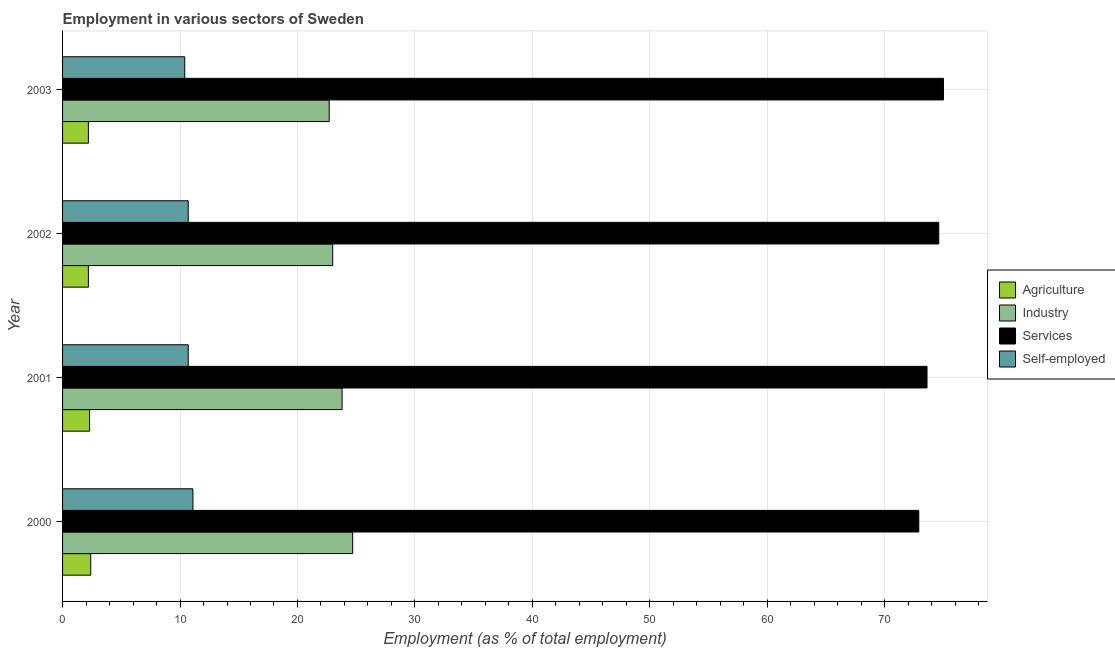How many groups of bars are there?
Make the answer very short. 4. Are the number of bars per tick equal to the number of legend labels?
Keep it short and to the point. Yes. How many bars are there on the 3rd tick from the top?
Give a very brief answer. 4. What is the percentage of workers in agriculture in 2002?
Your answer should be compact. 2.2. Across all years, what is the minimum percentage of workers in agriculture?
Your answer should be very brief. 2.2. In which year was the percentage of workers in services minimum?
Your answer should be very brief. 2000. What is the total percentage of workers in services in the graph?
Ensure brevity in your answer.  296.1. What is the difference between the percentage of workers in agriculture in 2000 and the percentage of workers in services in 2003?
Your response must be concise. -72.6. What is the average percentage of self employed workers per year?
Keep it short and to the point. 10.72. In the year 2003, what is the difference between the percentage of self employed workers and percentage of workers in services?
Provide a short and direct response. -64.6. In how many years, is the percentage of workers in services greater than 42 %?
Give a very brief answer. 4. Is the difference between the percentage of workers in industry in 2002 and 2003 greater than the difference between the percentage of self employed workers in 2002 and 2003?
Provide a short and direct response. No. What is the difference between the highest and the second highest percentage of workers in industry?
Ensure brevity in your answer.  0.9. Is it the case that in every year, the sum of the percentage of workers in agriculture and percentage of workers in industry is greater than the sum of percentage of self employed workers and percentage of workers in services?
Your answer should be very brief. Yes. What does the 1st bar from the top in 2002 represents?
Keep it short and to the point. Self-employed. What does the 2nd bar from the bottom in 2000 represents?
Offer a very short reply. Industry. Is it the case that in every year, the sum of the percentage of workers in agriculture and percentage of workers in industry is greater than the percentage of workers in services?
Give a very brief answer. No. Are all the bars in the graph horizontal?
Your response must be concise. Yes. What is the difference between two consecutive major ticks on the X-axis?
Give a very brief answer. 10. Are the values on the major ticks of X-axis written in scientific E-notation?
Offer a very short reply. No. Does the graph contain any zero values?
Give a very brief answer. No. Where does the legend appear in the graph?
Offer a terse response. Center right. What is the title of the graph?
Offer a very short reply. Employment in various sectors of Sweden. Does "Revenue mobilization" appear as one of the legend labels in the graph?
Your response must be concise. No. What is the label or title of the X-axis?
Make the answer very short. Employment (as % of total employment). What is the Employment (as % of total employment) of Agriculture in 2000?
Provide a short and direct response. 2.4. What is the Employment (as % of total employment) in Industry in 2000?
Provide a succinct answer. 24.7. What is the Employment (as % of total employment) in Services in 2000?
Your answer should be very brief. 72.9. What is the Employment (as % of total employment) of Self-employed in 2000?
Offer a very short reply. 11.1. What is the Employment (as % of total employment) in Agriculture in 2001?
Your answer should be compact. 2.3. What is the Employment (as % of total employment) of Industry in 2001?
Provide a succinct answer. 23.8. What is the Employment (as % of total employment) of Services in 2001?
Provide a short and direct response. 73.6. What is the Employment (as % of total employment) in Self-employed in 2001?
Provide a succinct answer. 10.7. What is the Employment (as % of total employment) of Agriculture in 2002?
Your answer should be compact. 2.2. What is the Employment (as % of total employment) in Services in 2002?
Your answer should be very brief. 74.6. What is the Employment (as % of total employment) of Self-employed in 2002?
Keep it short and to the point. 10.7. What is the Employment (as % of total employment) of Agriculture in 2003?
Provide a short and direct response. 2.2. What is the Employment (as % of total employment) of Industry in 2003?
Your answer should be very brief. 22.7. What is the Employment (as % of total employment) of Services in 2003?
Keep it short and to the point. 75. What is the Employment (as % of total employment) of Self-employed in 2003?
Keep it short and to the point. 10.4. Across all years, what is the maximum Employment (as % of total employment) in Agriculture?
Provide a short and direct response. 2.4. Across all years, what is the maximum Employment (as % of total employment) in Industry?
Offer a very short reply. 24.7. Across all years, what is the maximum Employment (as % of total employment) of Self-employed?
Your answer should be very brief. 11.1. Across all years, what is the minimum Employment (as % of total employment) in Agriculture?
Offer a terse response. 2.2. Across all years, what is the minimum Employment (as % of total employment) of Industry?
Provide a succinct answer. 22.7. Across all years, what is the minimum Employment (as % of total employment) of Services?
Your answer should be compact. 72.9. Across all years, what is the minimum Employment (as % of total employment) of Self-employed?
Ensure brevity in your answer.  10.4. What is the total Employment (as % of total employment) in Agriculture in the graph?
Keep it short and to the point. 9.1. What is the total Employment (as % of total employment) in Industry in the graph?
Offer a terse response. 94.2. What is the total Employment (as % of total employment) in Services in the graph?
Give a very brief answer. 296.1. What is the total Employment (as % of total employment) of Self-employed in the graph?
Your answer should be very brief. 42.9. What is the difference between the Employment (as % of total employment) of Agriculture in 2000 and that in 2001?
Keep it short and to the point. 0.1. What is the difference between the Employment (as % of total employment) in Agriculture in 2000 and that in 2002?
Offer a very short reply. 0.2. What is the difference between the Employment (as % of total employment) of Industry in 2000 and that in 2002?
Your answer should be compact. 1.7. What is the difference between the Employment (as % of total employment) in Agriculture in 2000 and that in 2003?
Keep it short and to the point. 0.2. What is the difference between the Employment (as % of total employment) of Industry in 2000 and that in 2003?
Offer a terse response. 2. What is the difference between the Employment (as % of total employment) in Agriculture in 2002 and that in 2003?
Your response must be concise. 0. What is the difference between the Employment (as % of total employment) of Services in 2002 and that in 2003?
Provide a short and direct response. -0.4. What is the difference between the Employment (as % of total employment) in Agriculture in 2000 and the Employment (as % of total employment) in Industry in 2001?
Provide a succinct answer. -21.4. What is the difference between the Employment (as % of total employment) in Agriculture in 2000 and the Employment (as % of total employment) in Services in 2001?
Provide a succinct answer. -71.2. What is the difference between the Employment (as % of total employment) in Industry in 2000 and the Employment (as % of total employment) in Services in 2001?
Give a very brief answer. -48.9. What is the difference between the Employment (as % of total employment) in Services in 2000 and the Employment (as % of total employment) in Self-employed in 2001?
Provide a succinct answer. 62.2. What is the difference between the Employment (as % of total employment) of Agriculture in 2000 and the Employment (as % of total employment) of Industry in 2002?
Your answer should be very brief. -20.6. What is the difference between the Employment (as % of total employment) of Agriculture in 2000 and the Employment (as % of total employment) of Services in 2002?
Your response must be concise. -72.2. What is the difference between the Employment (as % of total employment) of Industry in 2000 and the Employment (as % of total employment) of Services in 2002?
Ensure brevity in your answer.  -49.9. What is the difference between the Employment (as % of total employment) in Services in 2000 and the Employment (as % of total employment) in Self-employed in 2002?
Your answer should be compact. 62.2. What is the difference between the Employment (as % of total employment) in Agriculture in 2000 and the Employment (as % of total employment) in Industry in 2003?
Ensure brevity in your answer.  -20.3. What is the difference between the Employment (as % of total employment) of Agriculture in 2000 and the Employment (as % of total employment) of Services in 2003?
Provide a succinct answer. -72.6. What is the difference between the Employment (as % of total employment) of Industry in 2000 and the Employment (as % of total employment) of Services in 2003?
Give a very brief answer. -50.3. What is the difference between the Employment (as % of total employment) in Industry in 2000 and the Employment (as % of total employment) in Self-employed in 2003?
Your answer should be very brief. 14.3. What is the difference between the Employment (as % of total employment) of Services in 2000 and the Employment (as % of total employment) of Self-employed in 2003?
Make the answer very short. 62.5. What is the difference between the Employment (as % of total employment) in Agriculture in 2001 and the Employment (as % of total employment) in Industry in 2002?
Your answer should be compact. -20.7. What is the difference between the Employment (as % of total employment) of Agriculture in 2001 and the Employment (as % of total employment) of Services in 2002?
Give a very brief answer. -72.3. What is the difference between the Employment (as % of total employment) in Agriculture in 2001 and the Employment (as % of total employment) in Self-employed in 2002?
Ensure brevity in your answer.  -8.4. What is the difference between the Employment (as % of total employment) in Industry in 2001 and the Employment (as % of total employment) in Services in 2002?
Your answer should be very brief. -50.8. What is the difference between the Employment (as % of total employment) of Industry in 2001 and the Employment (as % of total employment) of Self-employed in 2002?
Provide a succinct answer. 13.1. What is the difference between the Employment (as % of total employment) of Services in 2001 and the Employment (as % of total employment) of Self-employed in 2002?
Your answer should be very brief. 62.9. What is the difference between the Employment (as % of total employment) of Agriculture in 2001 and the Employment (as % of total employment) of Industry in 2003?
Your response must be concise. -20.4. What is the difference between the Employment (as % of total employment) in Agriculture in 2001 and the Employment (as % of total employment) in Services in 2003?
Ensure brevity in your answer.  -72.7. What is the difference between the Employment (as % of total employment) in Industry in 2001 and the Employment (as % of total employment) in Services in 2003?
Keep it short and to the point. -51.2. What is the difference between the Employment (as % of total employment) of Industry in 2001 and the Employment (as % of total employment) of Self-employed in 2003?
Keep it short and to the point. 13.4. What is the difference between the Employment (as % of total employment) in Services in 2001 and the Employment (as % of total employment) in Self-employed in 2003?
Your answer should be compact. 63.2. What is the difference between the Employment (as % of total employment) in Agriculture in 2002 and the Employment (as % of total employment) in Industry in 2003?
Provide a succinct answer. -20.5. What is the difference between the Employment (as % of total employment) of Agriculture in 2002 and the Employment (as % of total employment) of Services in 2003?
Your answer should be compact. -72.8. What is the difference between the Employment (as % of total employment) in Industry in 2002 and the Employment (as % of total employment) in Services in 2003?
Provide a short and direct response. -52. What is the difference between the Employment (as % of total employment) in Industry in 2002 and the Employment (as % of total employment) in Self-employed in 2003?
Offer a terse response. 12.6. What is the difference between the Employment (as % of total employment) of Services in 2002 and the Employment (as % of total employment) of Self-employed in 2003?
Your response must be concise. 64.2. What is the average Employment (as % of total employment) of Agriculture per year?
Your response must be concise. 2.27. What is the average Employment (as % of total employment) of Industry per year?
Your answer should be very brief. 23.55. What is the average Employment (as % of total employment) of Services per year?
Ensure brevity in your answer.  74.03. What is the average Employment (as % of total employment) in Self-employed per year?
Ensure brevity in your answer.  10.72. In the year 2000, what is the difference between the Employment (as % of total employment) in Agriculture and Employment (as % of total employment) in Industry?
Make the answer very short. -22.3. In the year 2000, what is the difference between the Employment (as % of total employment) in Agriculture and Employment (as % of total employment) in Services?
Your response must be concise. -70.5. In the year 2000, what is the difference between the Employment (as % of total employment) of Agriculture and Employment (as % of total employment) of Self-employed?
Offer a very short reply. -8.7. In the year 2000, what is the difference between the Employment (as % of total employment) of Industry and Employment (as % of total employment) of Services?
Your answer should be very brief. -48.2. In the year 2000, what is the difference between the Employment (as % of total employment) in Services and Employment (as % of total employment) in Self-employed?
Your answer should be very brief. 61.8. In the year 2001, what is the difference between the Employment (as % of total employment) in Agriculture and Employment (as % of total employment) in Industry?
Give a very brief answer. -21.5. In the year 2001, what is the difference between the Employment (as % of total employment) in Agriculture and Employment (as % of total employment) in Services?
Your answer should be compact. -71.3. In the year 2001, what is the difference between the Employment (as % of total employment) of Industry and Employment (as % of total employment) of Services?
Your response must be concise. -49.8. In the year 2001, what is the difference between the Employment (as % of total employment) in Industry and Employment (as % of total employment) in Self-employed?
Ensure brevity in your answer.  13.1. In the year 2001, what is the difference between the Employment (as % of total employment) of Services and Employment (as % of total employment) of Self-employed?
Provide a succinct answer. 62.9. In the year 2002, what is the difference between the Employment (as % of total employment) of Agriculture and Employment (as % of total employment) of Industry?
Your answer should be compact. -20.8. In the year 2002, what is the difference between the Employment (as % of total employment) in Agriculture and Employment (as % of total employment) in Services?
Ensure brevity in your answer.  -72.4. In the year 2002, what is the difference between the Employment (as % of total employment) in Industry and Employment (as % of total employment) in Services?
Keep it short and to the point. -51.6. In the year 2002, what is the difference between the Employment (as % of total employment) of Industry and Employment (as % of total employment) of Self-employed?
Your answer should be compact. 12.3. In the year 2002, what is the difference between the Employment (as % of total employment) of Services and Employment (as % of total employment) of Self-employed?
Offer a terse response. 63.9. In the year 2003, what is the difference between the Employment (as % of total employment) in Agriculture and Employment (as % of total employment) in Industry?
Provide a succinct answer. -20.5. In the year 2003, what is the difference between the Employment (as % of total employment) in Agriculture and Employment (as % of total employment) in Services?
Make the answer very short. -72.8. In the year 2003, what is the difference between the Employment (as % of total employment) in Agriculture and Employment (as % of total employment) in Self-employed?
Your answer should be very brief. -8.2. In the year 2003, what is the difference between the Employment (as % of total employment) in Industry and Employment (as % of total employment) in Services?
Ensure brevity in your answer.  -52.3. In the year 2003, what is the difference between the Employment (as % of total employment) of Services and Employment (as % of total employment) of Self-employed?
Make the answer very short. 64.6. What is the ratio of the Employment (as % of total employment) in Agriculture in 2000 to that in 2001?
Give a very brief answer. 1.04. What is the ratio of the Employment (as % of total employment) of Industry in 2000 to that in 2001?
Make the answer very short. 1.04. What is the ratio of the Employment (as % of total employment) in Services in 2000 to that in 2001?
Your answer should be compact. 0.99. What is the ratio of the Employment (as % of total employment) of Self-employed in 2000 to that in 2001?
Offer a very short reply. 1.04. What is the ratio of the Employment (as % of total employment) of Agriculture in 2000 to that in 2002?
Keep it short and to the point. 1.09. What is the ratio of the Employment (as % of total employment) of Industry in 2000 to that in 2002?
Your answer should be compact. 1.07. What is the ratio of the Employment (as % of total employment) of Services in 2000 to that in 2002?
Provide a short and direct response. 0.98. What is the ratio of the Employment (as % of total employment) of Self-employed in 2000 to that in 2002?
Offer a very short reply. 1.04. What is the ratio of the Employment (as % of total employment) of Agriculture in 2000 to that in 2003?
Provide a short and direct response. 1.09. What is the ratio of the Employment (as % of total employment) of Industry in 2000 to that in 2003?
Your answer should be very brief. 1.09. What is the ratio of the Employment (as % of total employment) in Services in 2000 to that in 2003?
Keep it short and to the point. 0.97. What is the ratio of the Employment (as % of total employment) in Self-employed in 2000 to that in 2003?
Your response must be concise. 1.07. What is the ratio of the Employment (as % of total employment) of Agriculture in 2001 to that in 2002?
Offer a very short reply. 1.05. What is the ratio of the Employment (as % of total employment) in Industry in 2001 to that in 2002?
Ensure brevity in your answer.  1.03. What is the ratio of the Employment (as % of total employment) in Services in 2001 to that in 2002?
Provide a short and direct response. 0.99. What is the ratio of the Employment (as % of total employment) in Self-employed in 2001 to that in 2002?
Ensure brevity in your answer.  1. What is the ratio of the Employment (as % of total employment) in Agriculture in 2001 to that in 2003?
Provide a short and direct response. 1.05. What is the ratio of the Employment (as % of total employment) in Industry in 2001 to that in 2003?
Provide a succinct answer. 1.05. What is the ratio of the Employment (as % of total employment) of Services in 2001 to that in 2003?
Offer a terse response. 0.98. What is the ratio of the Employment (as % of total employment) of Self-employed in 2001 to that in 2003?
Ensure brevity in your answer.  1.03. What is the ratio of the Employment (as % of total employment) in Agriculture in 2002 to that in 2003?
Offer a terse response. 1. What is the ratio of the Employment (as % of total employment) in Industry in 2002 to that in 2003?
Give a very brief answer. 1.01. What is the ratio of the Employment (as % of total employment) in Services in 2002 to that in 2003?
Provide a succinct answer. 0.99. What is the ratio of the Employment (as % of total employment) of Self-employed in 2002 to that in 2003?
Ensure brevity in your answer.  1.03. What is the difference between the highest and the second highest Employment (as % of total employment) in Self-employed?
Offer a very short reply. 0.4. What is the difference between the highest and the lowest Employment (as % of total employment) of Industry?
Your answer should be compact. 2. What is the difference between the highest and the lowest Employment (as % of total employment) of Services?
Provide a succinct answer. 2.1. What is the difference between the highest and the lowest Employment (as % of total employment) of Self-employed?
Provide a succinct answer. 0.7. 